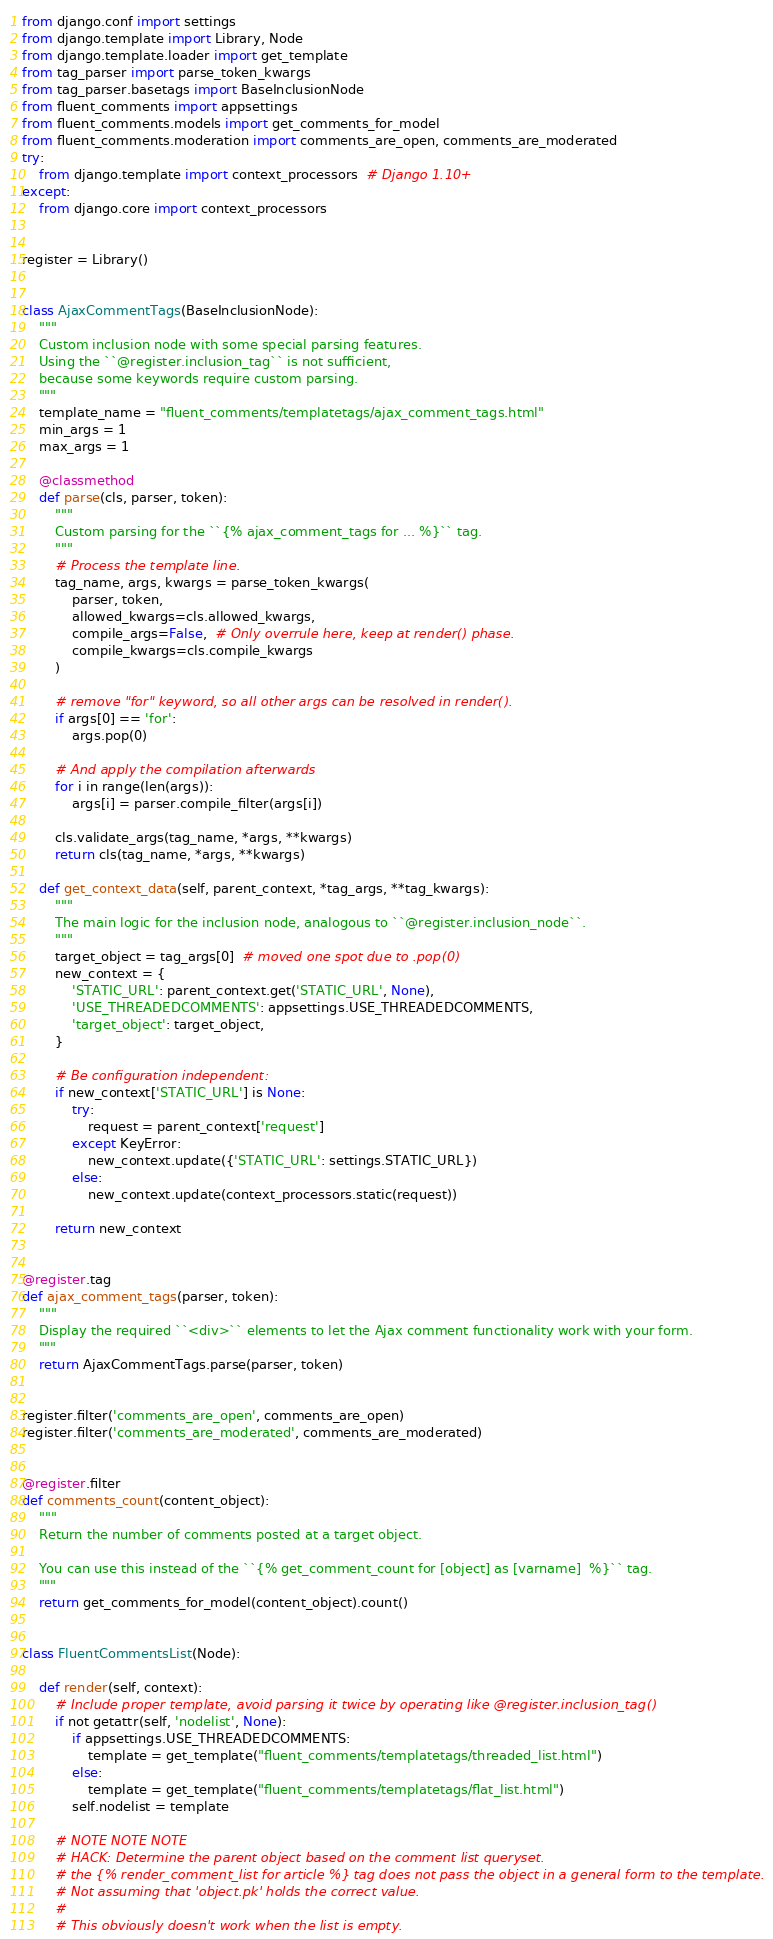<code> <loc_0><loc_0><loc_500><loc_500><_Python_>from django.conf import settings
from django.template import Library, Node
from django.template.loader import get_template
from tag_parser import parse_token_kwargs
from tag_parser.basetags import BaseInclusionNode
from fluent_comments import appsettings
from fluent_comments.models import get_comments_for_model
from fluent_comments.moderation import comments_are_open, comments_are_moderated
try:
    from django.template import context_processors  # Django 1.10+
except:
    from django.core import context_processors


register = Library()


class AjaxCommentTags(BaseInclusionNode):
    """
    Custom inclusion node with some special parsing features.
    Using the ``@register.inclusion_tag`` is not sufficient,
    because some keywords require custom parsing.
    """
    template_name = "fluent_comments/templatetags/ajax_comment_tags.html"
    min_args = 1
    max_args = 1

    @classmethod
    def parse(cls, parser, token):
        """
        Custom parsing for the ``{% ajax_comment_tags for ... %}`` tag.
        """
        # Process the template line.
        tag_name, args, kwargs = parse_token_kwargs(
            parser, token,
            allowed_kwargs=cls.allowed_kwargs,
            compile_args=False,  # Only overrule here, keep at render() phase.
            compile_kwargs=cls.compile_kwargs
        )

        # remove "for" keyword, so all other args can be resolved in render().
        if args[0] == 'for':
            args.pop(0)

        # And apply the compilation afterwards
        for i in range(len(args)):
            args[i] = parser.compile_filter(args[i])

        cls.validate_args(tag_name, *args, **kwargs)
        return cls(tag_name, *args, **kwargs)

    def get_context_data(self, parent_context, *tag_args, **tag_kwargs):
        """
        The main logic for the inclusion node, analogous to ``@register.inclusion_node``.
        """
        target_object = tag_args[0]  # moved one spot due to .pop(0)
        new_context = {
            'STATIC_URL': parent_context.get('STATIC_URL', None),
            'USE_THREADEDCOMMENTS': appsettings.USE_THREADEDCOMMENTS,
            'target_object': target_object,
        }

        # Be configuration independent:
        if new_context['STATIC_URL'] is None:
            try:
                request = parent_context['request']
            except KeyError:
                new_context.update({'STATIC_URL': settings.STATIC_URL})
            else:
                new_context.update(context_processors.static(request))

        return new_context


@register.tag
def ajax_comment_tags(parser, token):
    """
    Display the required ``<div>`` elements to let the Ajax comment functionality work with your form.
    """
    return AjaxCommentTags.parse(parser, token)


register.filter('comments_are_open', comments_are_open)
register.filter('comments_are_moderated', comments_are_moderated)


@register.filter
def comments_count(content_object):
    """
    Return the number of comments posted at a target object.

    You can use this instead of the ``{% get_comment_count for [object] as [varname]  %}`` tag.
    """
    return get_comments_for_model(content_object).count()


class FluentCommentsList(Node):

    def render(self, context):
        # Include proper template, avoid parsing it twice by operating like @register.inclusion_tag()
        if not getattr(self, 'nodelist', None):
            if appsettings.USE_THREADEDCOMMENTS:
                template = get_template("fluent_comments/templatetags/threaded_list.html")
            else:
                template = get_template("fluent_comments/templatetags/flat_list.html")
            self.nodelist = template

        # NOTE NOTE NOTE
        # HACK: Determine the parent object based on the comment list queryset.
        # the {% render_comment_list for article %} tag does not pass the object in a general form to the template.
        # Not assuming that 'object.pk' holds the correct value.
        #
        # This obviously doesn't work when the list is empty.</code> 